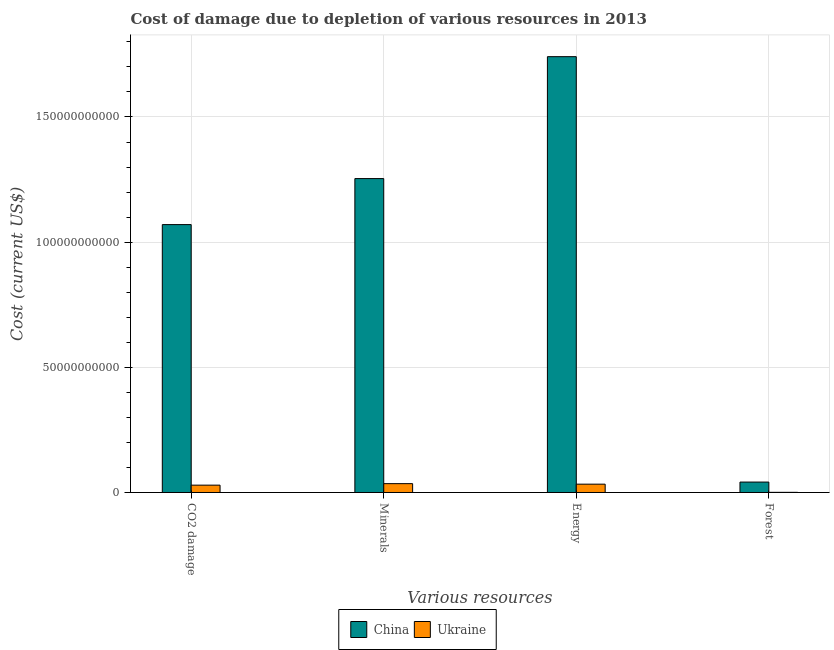How many groups of bars are there?
Make the answer very short. 4. How many bars are there on the 3rd tick from the right?
Ensure brevity in your answer.  2. What is the label of the 4th group of bars from the left?
Your answer should be compact. Forest. What is the cost of damage due to depletion of minerals in Ukraine?
Make the answer very short. 3.53e+09. Across all countries, what is the maximum cost of damage due to depletion of minerals?
Your answer should be compact. 1.25e+11. Across all countries, what is the minimum cost of damage due to depletion of energy?
Provide a succinct answer. 3.32e+09. In which country was the cost of damage due to depletion of forests maximum?
Keep it short and to the point. China. In which country was the cost of damage due to depletion of forests minimum?
Keep it short and to the point. Ukraine. What is the total cost of damage due to depletion of energy in the graph?
Offer a very short reply. 1.77e+11. What is the difference between the cost of damage due to depletion of energy in China and that in Ukraine?
Ensure brevity in your answer.  1.71e+11. What is the difference between the cost of damage due to depletion of coal in China and the cost of damage due to depletion of energy in Ukraine?
Keep it short and to the point. 1.04e+11. What is the average cost of damage due to depletion of minerals per country?
Make the answer very short. 6.45e+1. What is the difference between the cost of damage due to depletion of energy and cost of damage due to depletion of forests in China?
Offer a very short reply. 1.70e+11. What is the ratio of the cost of damage due to depletion of coal in China to that in Ukraine?
Provide a short and direct response. 36.49. Is the cost of damage due to depletion of coal in Ukraine less than that in China?
Your answer should be very brief. Yes. What is the difference between the highest and the second highest cost of damage due to depletion of minerals?
Your answer should be very brief. 1.22e+11. What is the difference between the highest and the lowest cost of damage due to depletion of forests?
Ensure brevity in your answer.  4.10e+09. In how many countries, is the cost of damage due to depletion of forests greater than the average cost of damage due to depletion of forests taken over all countries?
Ensure brevity in your answer.  1. Is the sum of the cost of damage due to depletion of coal in Ukraine and China greater than the maximum cost of damage due to depletion of energy across all countries?
Keep it short and to the point. No. Is it the case that in every country, the sum of the cost of damage due to depletion of coal and cost of damage due to depletion of minerals is greater than the sum of cost of damage due to depletion of energy and cost of damage due to depletion of forests?
Make the answer very short. Yes. What does the 1st bar from the right in Forest represents?
Offer a terse response. Ukraine. Is it the case that in every country, the sum of the cost of damage due to depletion of coal and cost of damage due to depletion of minerals is greater than the cost of damage due to depletion of energy?
Ensure brevity in your answer.  Yes. How many bars are there?
Give a very brief answer. 8. Are all the bars in the graph horizontal?
Offer a terse response. No. How many countries are there in the graph?
Give a very brief answer. 2. What is the difference between two consecutive major ticks on the Y-axis?
Your response must be concise. 5.00e+1. Does the graph contain grids?
Make the answer very short. Yes. How many legend labels are there?
Offer a terse response. 2. How are the legend labels stacked?
Make the answer very short. Horizontal. What is the title of the graph?
Ensure brevity in your answer.  Cost of damage due to depletion of various resources in 2013 . Does "High income: nonOECD" appear as one of the legend labels in the graph?
Offer a very short reply. No. What is the label or title of the X-axis?
Ensure brevity in your answer.  Various resources. What is the label or title of the Y-axis?
Your response must be concise. Cost (current US$). What is the Cost (current US$) in China in CO2 damage?
Your answer should be compact. 1.07e+11. What is the Cost (current US$) of Ukraine in CO2 damage?
Provide a succinct answer. 2.93e+09. What is the Cost (current US$) in China in Minerals?
Give a very brief answer. 1.25e+11. What is the Cost (current US$) in Ukraine in Minerals?
Ensure brevity in your answer.  3.53e+09. What is the Cost (current US$) of China in Energy?
Keep it short and to the point. 1.74e+11. What is the Cost (current US$) in Ukraine in Energy?
Your answer should be very brief. 3.32e+09. What is the Cost (current US$) of China in Forest?
Ensure brevity in your answer.  4.16e+09. What is the Cost (current US$) of Ukraine in Forest?
Your response must be concise. 6.24e+07. Across all Various resources, what is the maximum Cost (current US$) of China?
Provide a short and direct response. 1.74e+11. Across all Various resources, what is the maximum Cost (current US$) of Ukraine?
Provide a succinct answer. 3.53e+09. Across all Various resources, what is the minimum Cost (current US$) in China?
Your response must be concise. 4.16e+09. Across all Various resources, what is the minimum Cost (current US$) in Ukraine?
Your answer should be very brief. 6.24e+07. What is the total Cost (current US$) in China in the graph?
Give a very brief answer. 4.11e+11. What is the total Cost (current US$) of Ukraine in the graph?
Your answer should be very brief. 9.85e+09. What is the difference between the Cost (current US$) in China in CO2 damage and that in Minerals?
Keep it short and to the point. -1.84e+1. What is the difference between the Cost (current US$) of Ukraine in CO2 damage and that in Minerals?
Your response must be concise. -6.01e+08. What is the difference between the Cost (current US$) of China in CO2 damage and that in Energy?
Your response must be concise. -6.71e+1. What is the difference between the Cost (current US$) of Ukraine in CO2 damage and that in Energy?
Ensure brevity in your answer.  -3.90e+08. What is the difference between the Cost (current US$) of China in CO2 damage and that in Forest?
Your response must be concise. 1.03e+11. What is the difference between the Cost (current US$) in Ukraine in CO2 damage and that in Forest?
Your response must be concise. 2.87e+09. What is the difference between the Cost (current US$) in China in Minerals and that in Energy?
Provide a succinct answer. -4.87e+1. What is the difference between the Cost (current US$) of Ukraine in Minerals and that in Energy?
Make the answer very short. 2.11e+08. What is the difference between the Cost (current US$) of China in Minerals and that in Forest?
Your answer should be very brief. 1.21e+11. What is the difference between the Cost (current US$) in Ukraine in Minerals and that in Forest?
Offer a terse response. 3.47e+09. What is the difference between the Cost (current US$) of China in Energy and that in Forest?
Keep it short and to the point. 1.70e+11. What is the difference between the Cost (current US$) of Ukraine in Energy and that in Forest?
Offer a very short reply. 3.26e+09. What is the difference between the Cost (current US$) in China in CO2 damage and the Cost (current US$) in Ukraine in Minerals?
Offer a very short reply. 1.03e+11. What is the difference between the Cost (current US$) in China in CO2 damage and the Cost (current US$) in Ukraine in Energy?
Give a very brief answer. 1.04e+11. What is the difference between the Cost (current US$) of China in CO2 damage and the Cost (current US$) of Ukraine in Forest?
Your answer should be compact. 1.07e+11. What is the difference between the Cost (current US$) in China in Minerals and the Cost (current US$) in Ukraine in Energy?
Your response must be concise. 1.22e+11. What is the difference between the Cost (current US$) of China in Minerals and the Cost (current US$) of Ukraine in Forest?
Your answer should be compact. 1.25e+11. What is the difference between the Cost (current US$) of China in Energy and the Cost (current US$) of Ukraine in Forest?
Give a very brief answer. 1.74e+11. What is the average Cost (current US$) in China per Various resources?
Provide a succinct answer. 1.03e+11. What is the average Cost (current US$) of Ukraine per Various resources?
Make the answer very short. 2.46e+09. What is the difference between the Cost (current US$) in China and Cost (current US$) in Ukraine in CO2 damage?
Keep it short and to the point. 1.04e+11. What is the difference between the Cost (current US$) in China and Cost (current US$) in Ukraine in Minerals?
Your response must be concise. 1.22e+11. What is the difference between the Cost (current US$) of China and Cost (current US$) of Ukraine in Energy?
Give a very brief answer. 1.71e+11. What is the difference between the Cost (current US$) in China and Cost (current US$) in Ukraine in Forest?
Your answer should be compact. 4.10e+09. What is the ratio of the Cost (current US$) in China in CO2 damage to that in Minerals?
Make the answer very short. 0.85. What is the ratio of the Cost (current US$) in Ukraine in CO2 damage to that in Minerals?
Offer a very short reply. 0.83. What is the ratio of the Cost (current US$) in China in CO2 damage to that in Energy?
Your answer should be very brief. 0.61. What is the ratio of the Cost (current US$) of Ukraine in CO2 damage to that in Energy?
Ensure brevity in your answer.  0.88. What is the ratio of the Cost (current US$) of China in CO2 damage to that in Forest?
Offer a terse response. 25.7. What is the ratio of the Cost (current US$) of Ukraine in CO2 damage to that in Forest?
Offer a terse response. 46.99. What is the ratio of the Cost (current US$) in China in Minerals to that in Energy?
Offer a very short reply. 0.72. What is the ratio of the Cost (current US$) in Ukraine in Minerals to that in Energy?
Your answer should be compact. 1.06. What is the ratio of the Cost (current US$) of China in Minerals to that in Forest?
Provide a short and direct response. 30.12. What is the ratio of the Cost (current US$) in Ukraine in Minerals to that in Forest?
Your answer should be compact. 56.61. What is the ratio of the Cost (current US$) in China in Energy to that in Forest?
Make the answer very short. 41.82. What is the ratio of the Cost (current US$) in Ukraine in Energy to that in Forest?
Your answer should be compact. 53.23. What is the difference between the highest and the second highest Cost (current US$) in China?
Provide a succinct answer. 4.87e+1. What is the difference between the highest and the second highest Cost (current US$) of Ukraine?
Your answer should be very brief. 2.11e+08. What is the difference between the highest and the lowest Cost (current US$) of China?
Offer a very short reply. 1.70e+11. What is the difference between the highest and the lowest Cost (current US$) in Ukraine?
Make the answer very short. 3.47e+09. 